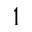<formula> <loc_0><loc_0><loc_500><loc_500>1</formula> 